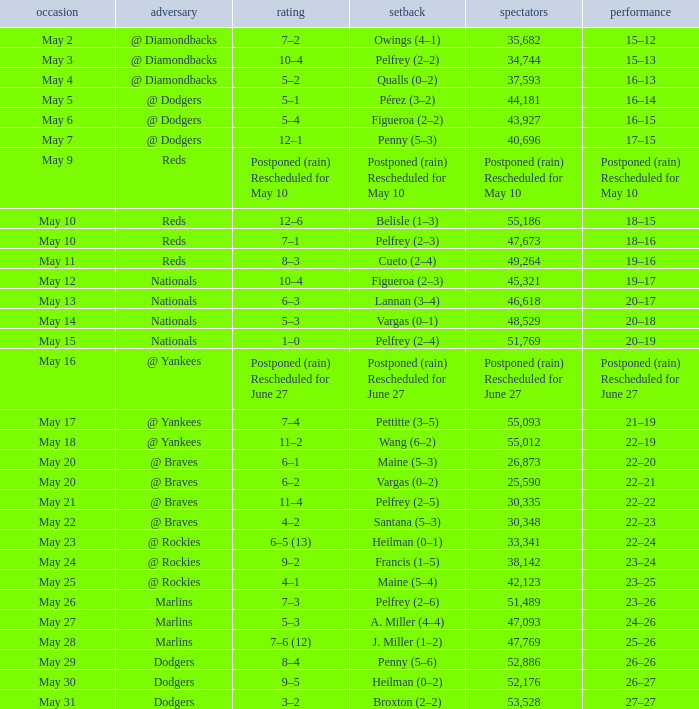Record of 19–16 occurred on what date? May 11. 